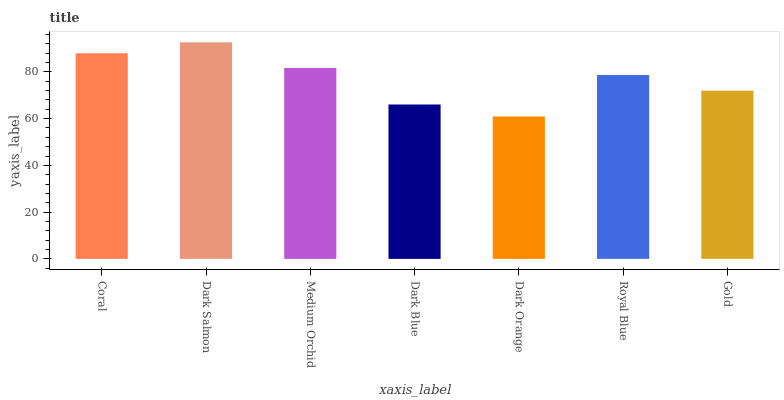Is Dark Orange the minimum?
Answer yes or no. Yes. Is Dark Salmon the maximum?
Answer yes or no. Yes. Is Medium Orchid the minimum?
Answer yes or no. No. Is Medium Orchid the maximum?
Answer yes or no. No. Is Dark Salmon greater than Medium Orchid?
Answer yes or no. Yes. Is Medium Orchid less than Dark Salmon?
Answer yes or no. Yes. Is Medium Orchid greater than Dark Salmon?
Answer yes or no. No. Is Dark Salmon less than Medium Orchid?
Answer yes or no. No. Is Royal Blue the high median?
Answer yes or no. Yes. Is Royal Blue the low median?
Answer yes or no. Yes. Is Dark Salmon the high median?
Answer yes or no. No. Is Medium Orchid the low median?
Answer yes or no. No. 